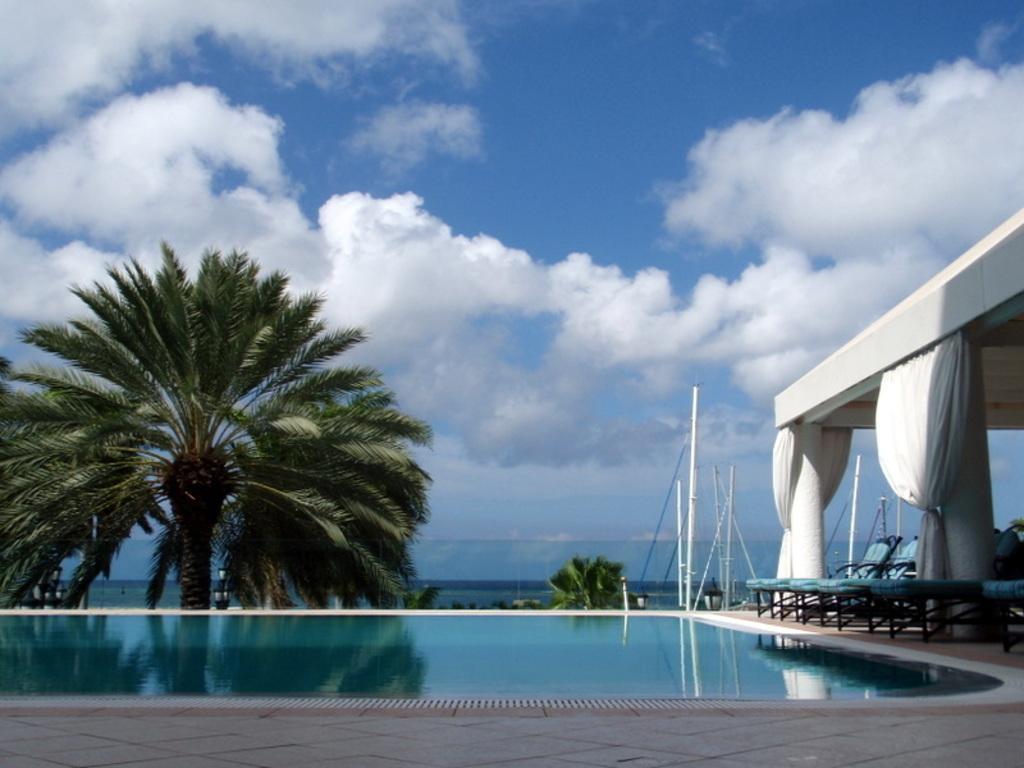Please provide a concise description of this image. In this image we can see the pool and also the pool beds on the path. We can also see the trees, white color poles, pillars, curtains and also the ceiling. In the background we can see the sky with the clouds. 